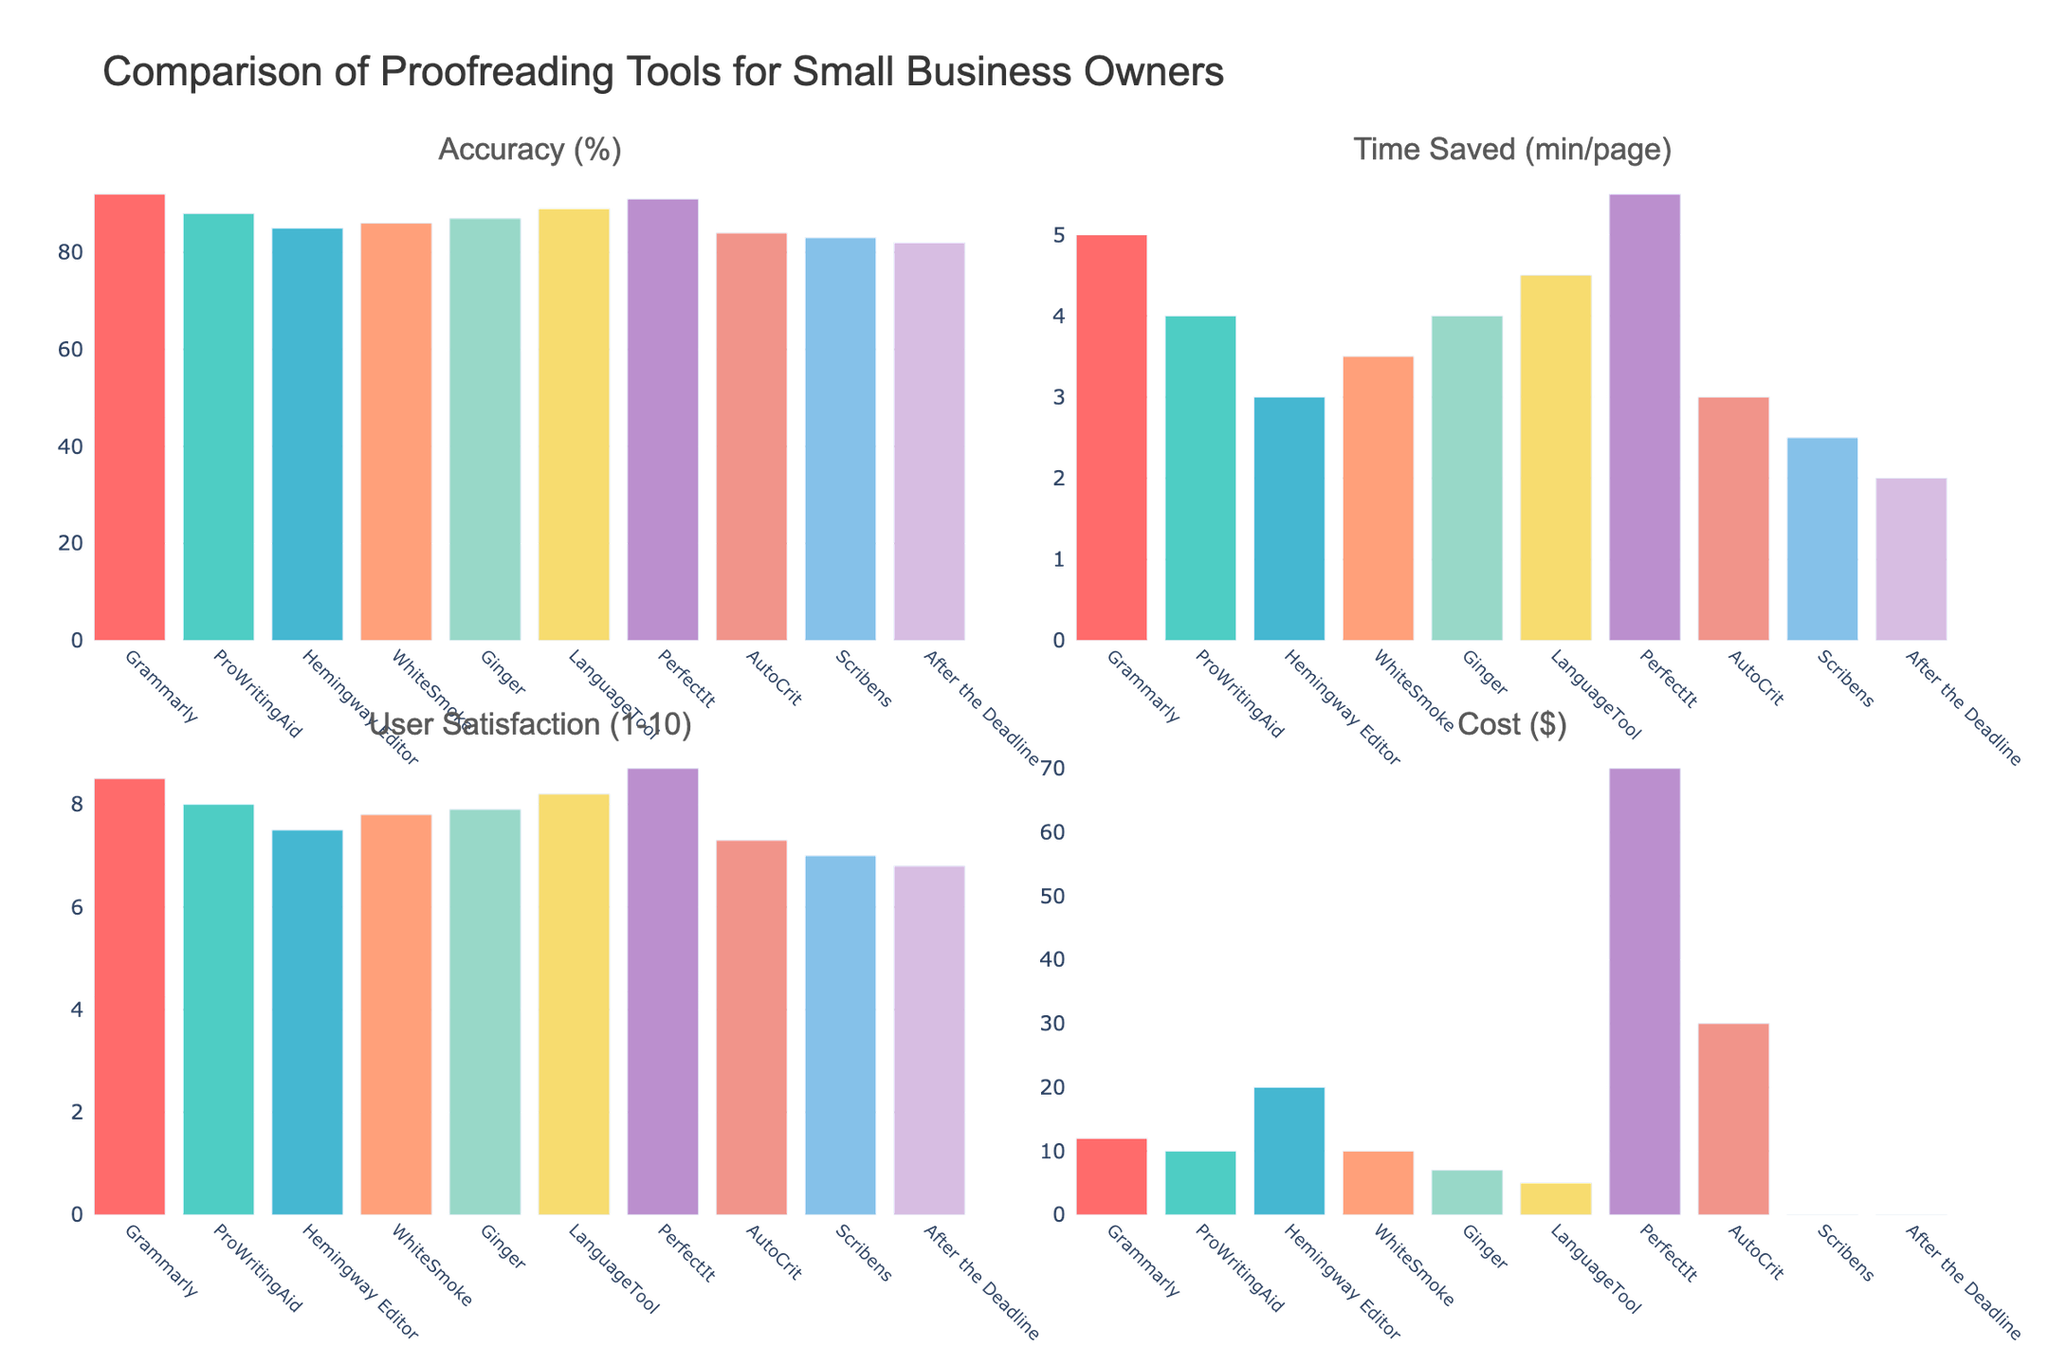Which proofreading tool has the highest accuracy? By inspecting the bar heights for the "Accuracy (%)" subplot, we see PerfectIt has the tallest bar indicating the highest accuracy at 91%.
Answer: PerfectIt Which tool saves the most time per page? By examining the "Time Saved (min/page)" subplot, we notice PerfectIt has the highest bar height indicating it saves the most time per page at 5.5 minutes.
Answer: PerfectIt What is the difference in user satisfaction between Grammarly and Hemingway Editor? Look at the "User Satisfaction (1-10)" subplot and compare the heights of the bars for Grammarly (8.5) and Hemingway Editor (7.5). The difference is 8.5 - 7.5 = 1.0.
Answer: 1.0 Which tool is the most cost-effective considering the cost per minute saved? First, calculate the cost per minute saved for each tool by dividing the cost by the time saved. PerfectIt costs $70 and saves 5.5 minutes, so cost per minute saved is 70 / 5.5 ≈ 12.7. Repeat this calculation for all tools and compare. LanguageTool has the lowest cost per minute saved which is 5 / 4.5 ≈ 1.1.
Answer: LanguageTool Do any tools have the same cost but different user satisfaction ratings? Compare the "Cost ($)" and "User Satisfaction (1-10)" subplots. WhiteSmoke and ProWritingAid both cost $10, but WhiteSmoke has a user satisfaction rating of 7.8, while ProWritingAid has 8.0.
Answer: Yes, WhiteSmoke and ProWritingAid Which tool has the lowest accuracy and what is its user satisfaction score? Look at the "Accuracy (%)" subplot, the shortest bar belongs to After the Deadline with an accuracy of 82%. Now check the user satisfaction in the corresponding subplot, which is 6.8.
Answer: After the Deadline; 6.8 If a user prioritizes low cost and high accuracy, which tool should they choose? Look for the tools with the lowest cost in the "Cost ($)" subplot. LanguageTool has a low cost of $5 and a high accuracy of 89%.
Answer: LanguageTool What is the average user satisfaction rating for all tools? Sum the user satisfaction ratings and divide by the number of tools: (8.5 + 8.0 + 7.5 + 7.8 + 7.9 + 8.2 + 8.7 + 7.3 + 7.0 + 6.8) / 10 = 7.77.
Answer: 7.77 Which tools have an accuracy greater than 90%? In the "Accuracy (%)" subplot, identify the bars taller than 90%. Grammarly (92%) and PerfectIt (91%) meet this criterion.
Answer: Grammarly, PerfectIt 